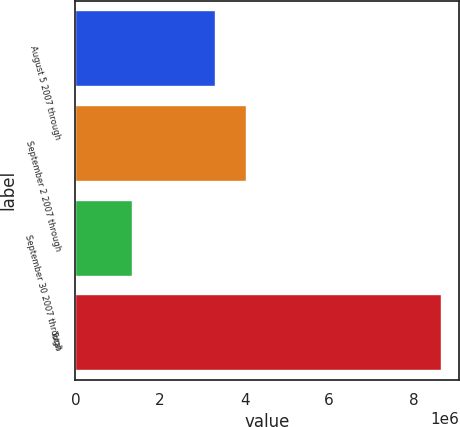Convert chart. <chart><loc_0><loc_0><loc_500><loc_500><bar_chart><fcel>August 5 2007 through<fcel>September 2 2007 through<fcel>September 30 2007 through<fcel>Total<nl><fcel>3.31077e+06<fcel>4.04176e+06<fcel>1.33377e+06<fcel>8.64373e+06<nl></chart> 